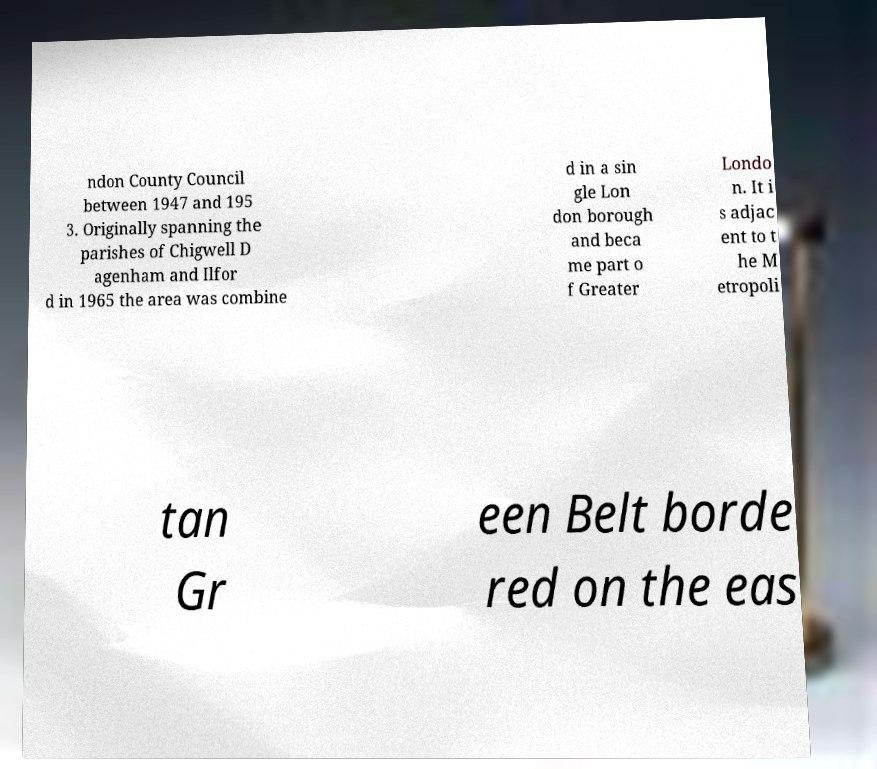Please identify and transcribe the text found in this image. ndon County Council between 1947 and 195 3. Originally spanning the parishes of Chigwell D agenham and Ilfor d in 1965 the area was combine d in a sin gle Lon don borough and beca me part o f Greater Londo n. It i s adjac ent to t he M etropoli tan Gr een Belt borde red on the eas 